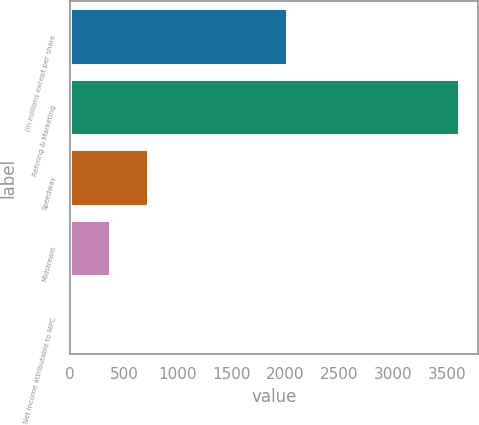<chart> <loc_0><loc_0><loc_500><loc_500><bar_chart><fcel>(In millions except per share<fcel>Refining & Marketing<fcel>Speedway<fcel>Midstream<fcel>Net income attributable to MPC<nl><fcel>2014<fcel>3609<fcel>725.31<fcel>364.85<fcel>4.39<nl></chart> 